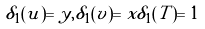<formula> <loc_0><loc_0><loc_500><loc_500>\delta _ { 1 } ( u ) = y , \delta _ { 1 } ( v ) = x \delta _ { 1 } ( T ) = 1</formula> 